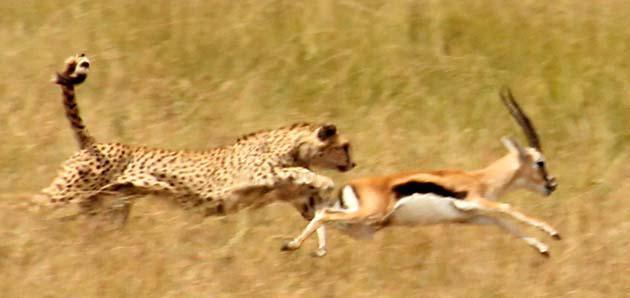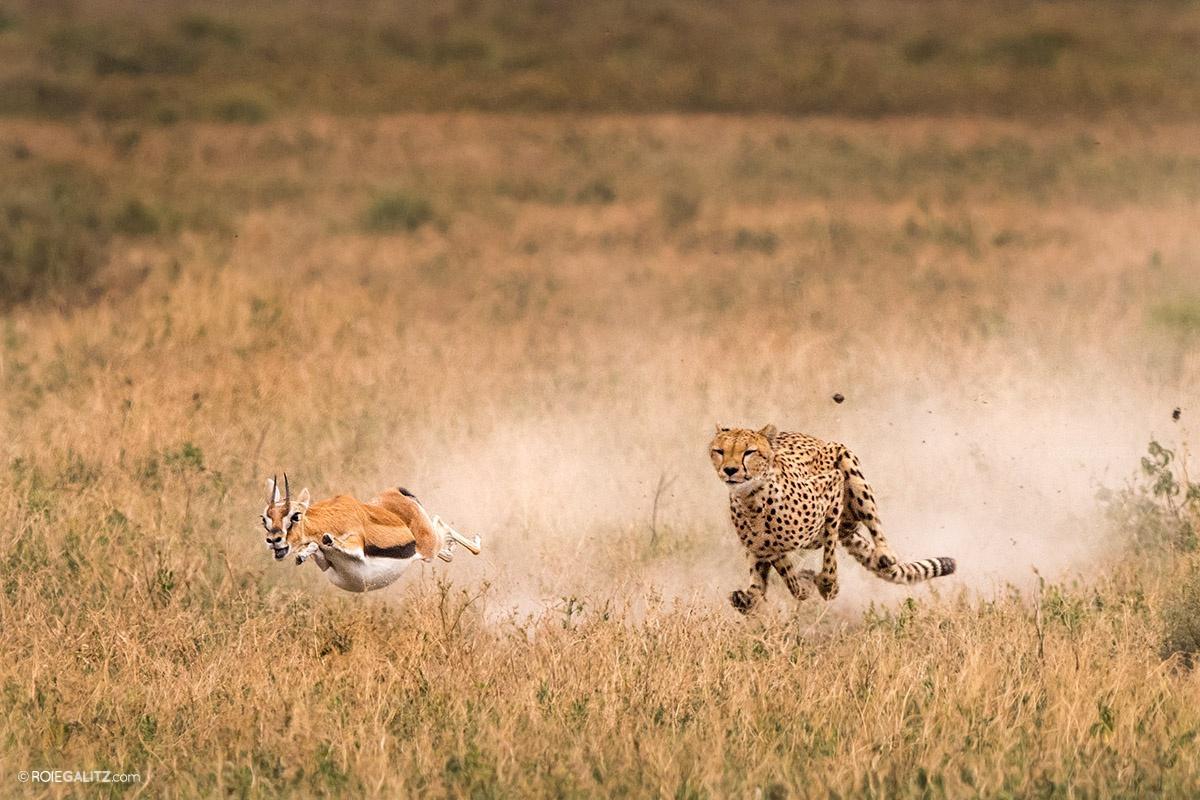The first image is the image on the left, the second image is the image on the right. Evaluate the accuracy of this statement regarding the images: "In the left image there is one cheetah and it is running towards the left.". Is it true? Answer yes or no. No. The first image is the image on the left, the second image is the image on the right. Considering the images on both sides, is "At least one of the images contains a single large cat chasing a single animal with no other animals present." valid? Answer yes or no. Yes. 